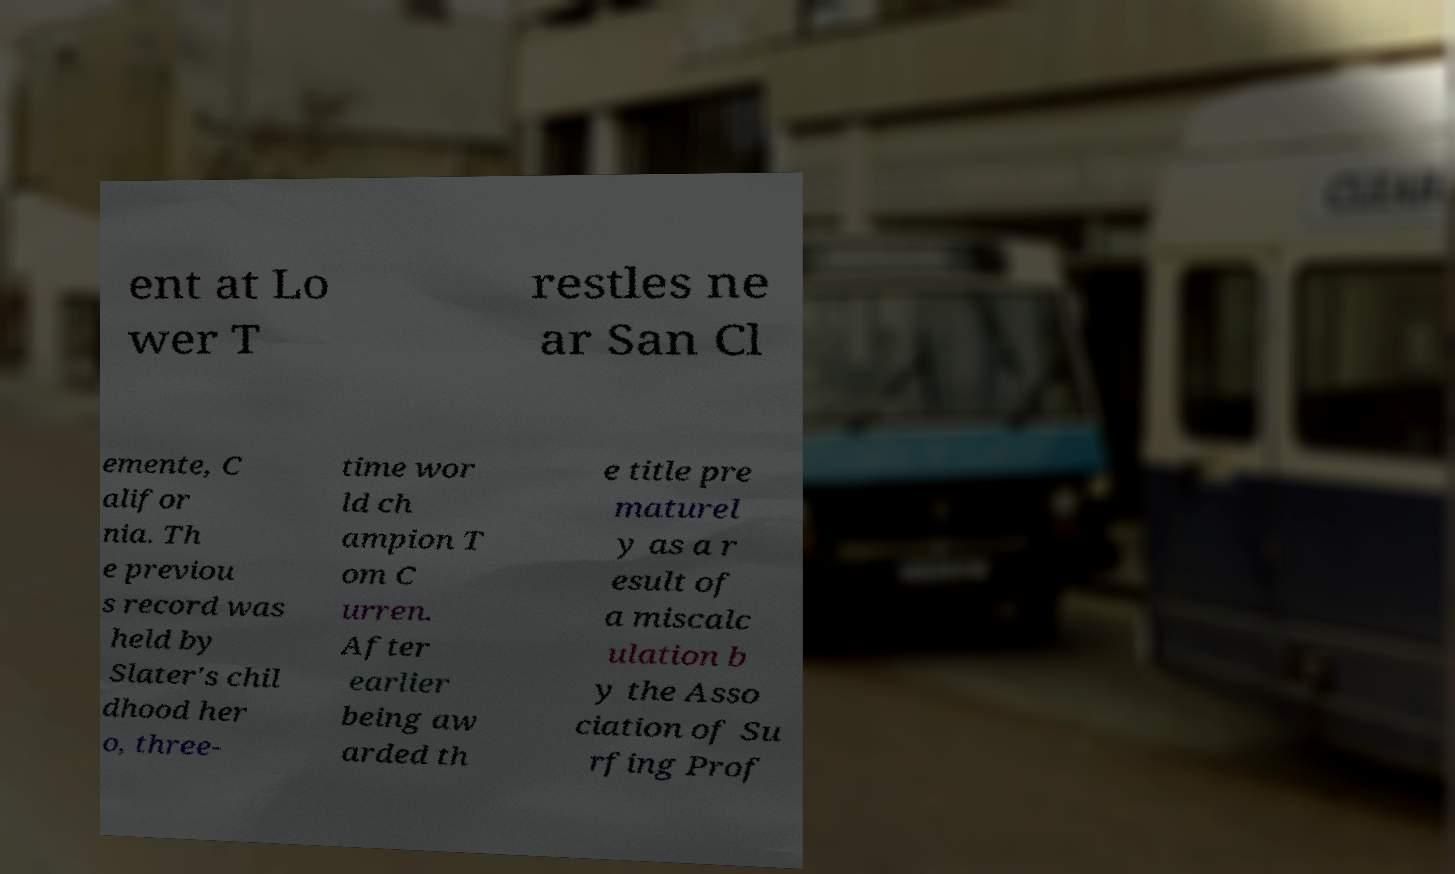Can you accurately transcribe the text from the provided image for me? ent at Lo wer T restles ne ar San Cl emente, C alifor nia. Th e previou s record was held by Slater's chil dhood her o, three- time wor ld ch ampion T om C urren. After earlier being aw arded th e title pre maturel y as a r esult of a miscalc ulation b y the Asso ciation of Su rfing Prof 